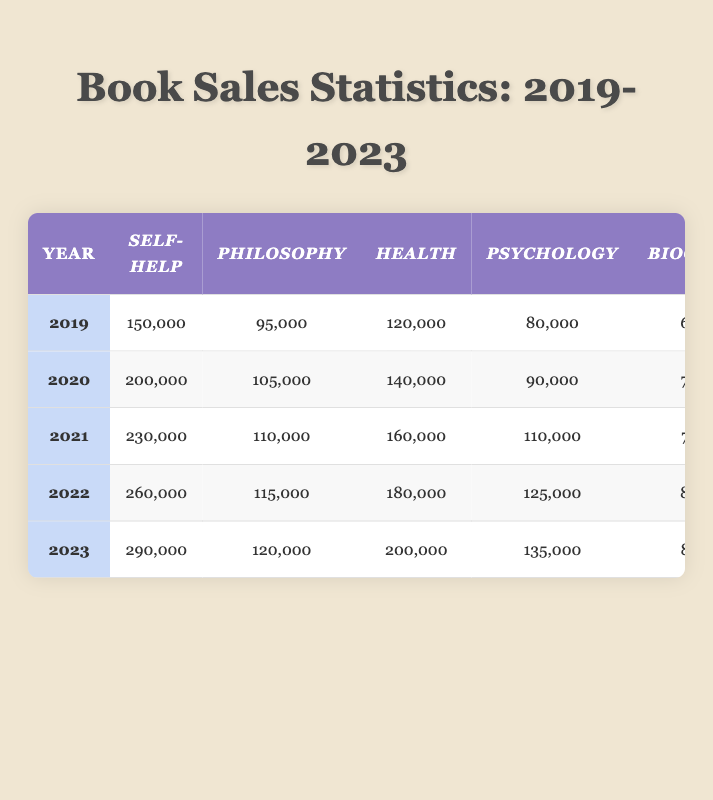What was the total number of self-help books sold in 2022? In 2022, the number of self-help books sold was 260,000, as indicated in the table for that year.
Answer: 260,000 Which genre had the highest sales in 2020? In 2020, fiction had the highest sales with 370,000 books sold, compared to other genres listed in the table for that year.
Answer: Fiction How much did self-help book sales increase from 2019 to 2023? In 2019, self-help book sales were 150,000, and in 2023, they were 290,000. The increase is 290,000 - 150,000 = 140,000.
Answer: 140,000 Did philosophy book sales decrease from 2020 to 2021? Philosophy book sales in 2020 were 105,000 and in 2021 were 110,000. Since 110,000 is greater than 105,000, sales did not decrease.
Answer: No What is the average number of biography books sold from 2019 to 2023? The sales figures for biography from 2019 to 2023 are: 60,000, 70,000, 75,000, 80,000, and 85,000. The sum is 370,000 and dividing by 5 gives an average of 370,000 / 5 = 74,000.
Answer: 74,000 In which year did health book sales peak? Reviewing the data, health book sales increased each year from 2019 to 2023, with the peak reaching 200,000 in 2023, the last year listed.
Answer: 2023 What was the increase in psychology book sales from 2021 to 2022? In 2021, there were 110,000 psychology books sold, and in 2022, there were 125,000. The increase is 125,000 - 110,000 = 15,000.
Answer: 15,000 Which genre had the lowest sales in 2019? In 2019, biography had the lowest sales with 60,000, as compared to the other genres listed for that year.
Answer: Biography How many more fiction books were sold in 2023 than in 2021? In 2023, 450,000 fiction books were sold, and in 2021, 400,000 were sold. The difference is 450,000 - 400,000 = 50,000 more in 2023.
Answer: 50,000 Is it true that philosophy book sales have shown consistent growth from 2019 to 2023? The sales for philosophy went from 95,000 in 2019 to 120,000 in 2023, showing consistent growth each year.
Answer: Yes What is the total sales for health books from 2019 to 2023? The health book sales figures are: 120,000 (2019), 140,000 (2020), 160,000 (2021), 180,000 (2022), and 200,000 (2023). The sum is 1,000,000.
Answer: 1,000,000 